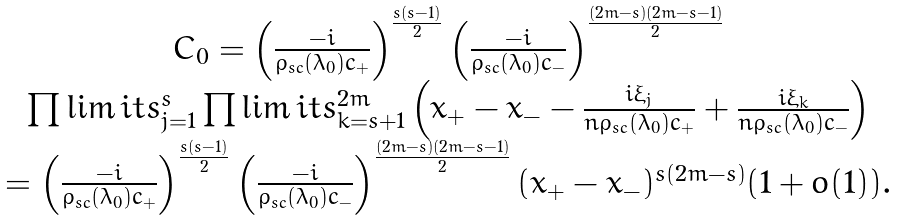<formula> <loc_0><loc_0><loc_500><loc_500>\begin{array} { c } C _ { 0 } = \left ( \frac { - i } { \rho _ { s c } ( \lambda _ { 0 } ) c _ { + } } \right ) ^ { \frac { s ( s - 1 ) } { 2 } } \left ( \frac { - i } { \rho _ { s c } ( \lambda _ { 0 } ) c _ { - } } \right ) ^ { \frac { ( 2 m - s ) ( 2 m - s - 1 ) } { 2 } } \\ \prod \lim i t s _ { j = 1 } ^ { s } \prod \lim i t s _ { k = s + 1 } ^ { 2 m } \left ( x _ { + } - x _ { - } - \frac { i \xi _ { j } } { n \rho _ { s c } ( \lambda _ { 0 } ) c _ { + } } + \frac { i \xi _ { k } } { n \rho _ { s c } ( \lambda _ { 0 } ) c _ { - } } \right ) \\ = \left ( \frac { - i } { \rho _ { s c } ( \lambda _ { 0 } ) c _ { + } } \right ) ^ { \frac { s ( s - 1 ) } { 2 } } \left ( \frac { - i } { \rho _ { s c } ( \lambda _ { 0 } ) c _ { - } } \right ) ^ { \frac { ( 2 m - s ) ( 2 m - s - 1 ) } { 2 } } ( x _ { + } - x _ { - } ) ^ { s ( 2 m - s ) } ( 1 + o ( 1 ) ) . \end{array}</formula> 